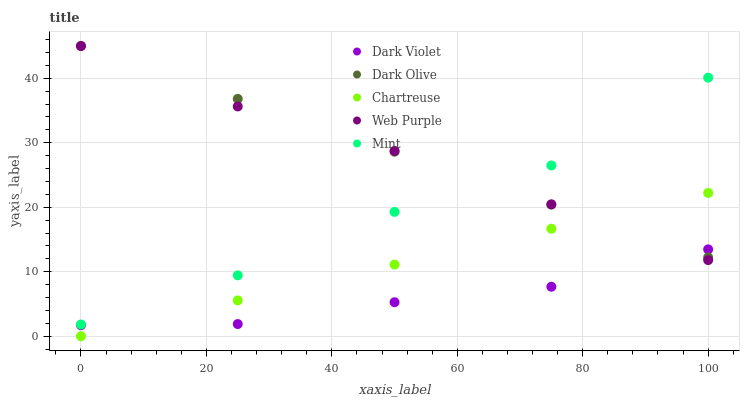Does Dark Violet have the minimum area under the curve?
Answer yes or no. Yes. Does Dark Olive have the maximum area under the curve?
Answer yes or no. Yes. Does Mint have the minimum area under the curve?
Answer yes or no. No. Does Mint have the maximum area under the curve?
Answer yes or no. No. Is Chartreuse the smoothest?
Answer yes or no. Yes. Is Mint the roughest?
Answer yes or no. Yes. Is Dark Olive the smoothest?
Answer yes or no. No. Is Dark Olive the roughest?
Answer yes or no. No. Does Chartreuse have the lowest value?
Answer yes or no. Yes. Does Mint have the lowest value?
Answer yes or no. No. Does Web Purple have the highest value?
Answer yes or no. Yes. Does Mint have the highest value?
Answer yes or no. No. Is Chartreuse less than Mint?
Answer yes or no. Yes. Is Mint greater than Dark Violet?
Answer yes or no. Yes. Does Chartreuse intersect Web Purple?
Answer yes or no. Yes. Is Chartreuse less than Web Purple?
Answer yes or no. No. Is Chartreuse greater than Web Purple?
Answer yes or no. No. Does Chartreuse intersect Mint?
Answer yes or no. No. 